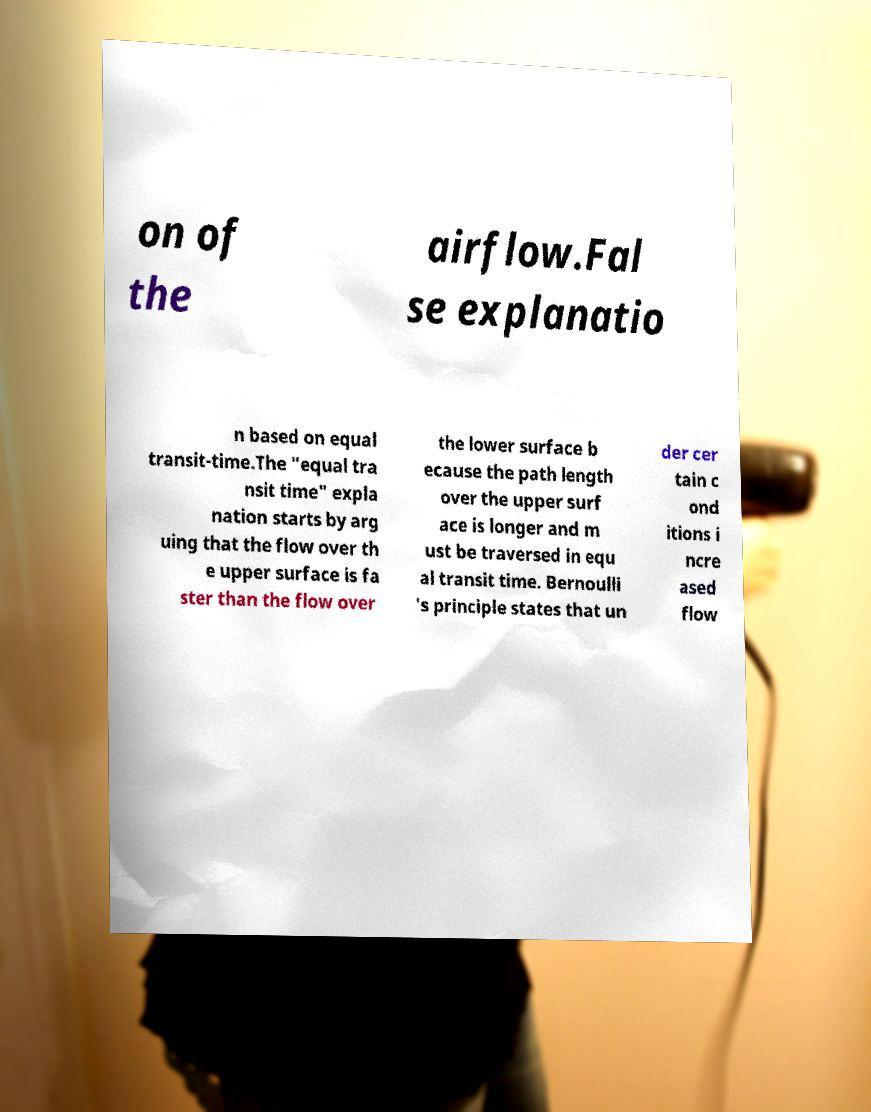Could you assist in decoding the text presented in this image and type it out clearly? on of the airflow.Fal se explanatio n based on equal transit-time.The "equal tra nsit time" expla nation starts by arg uing that the flow over th e upper surface is fa ster than the flow over the lower surface b ecause the path length over the upper surf ace is longer and m ust be traversed in equ al transit time. Bernoulli 's principle states that un der cer tain c ond itions i ncre ased flow 